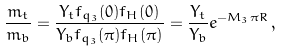Convert formula to latex. <formula><loc_0><loc_0><loc_500><loc_500>\frac { m _ { t } } { m _ { b } } = \frac { Y _ { t } f _ { q _ { 3 } } ( 0 ) f _ { H } ( 0 ) } { Y _ { b } f _ { q _ { 3 } } ( \pi ) f _ { H } ( \pi ) } = \frac { Y _ { t } } { Y _ { b } } e ^ { - M _ { 3 } \pi R } \, ,</formula> 